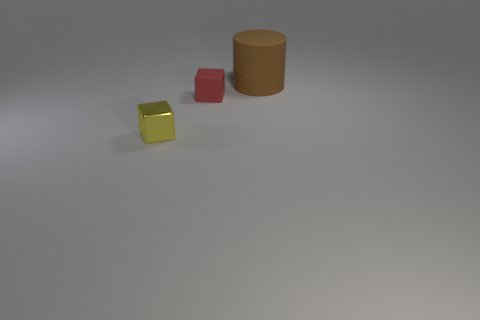Add 3 matte cylinders. How many objects exist? 6 Subtract all blue blocks. Subtract all green balls. How many blocks are left? 2 Subtract all purple blocks. How many cyan cylinders are left? 0 Subtract all large purple metal objects. Subtract all small things. How many objects are left? 1 Add 1 blocks. How many blocks are left? 3 Add 1 small yellow objects. How many small yellow objects exist? 2 Subtract all red blocks. How many blocks are left? 1 Subtract 1 brown cylinders. How many objects are left? 2 Subtract all cylinders. How many objects are left? 2 